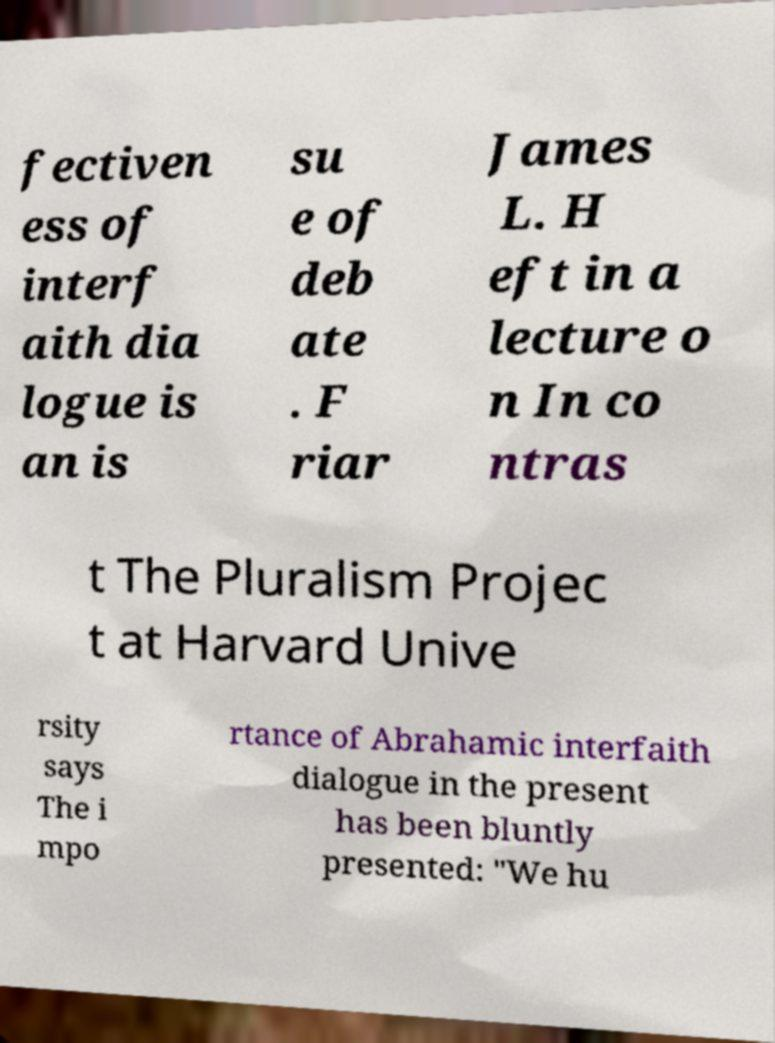Could you extract and type out the text from this image? fectiven ess of interf aith dia logue is an is su e of deb ate . F riar James L. H eft in a lecture o n In co ntras t The Pluralism Projec t at Harvard Unive rsity says The i mpo rtance of Abrahamic interfaith dialogue in the present has been bluntly presented: "We hu 